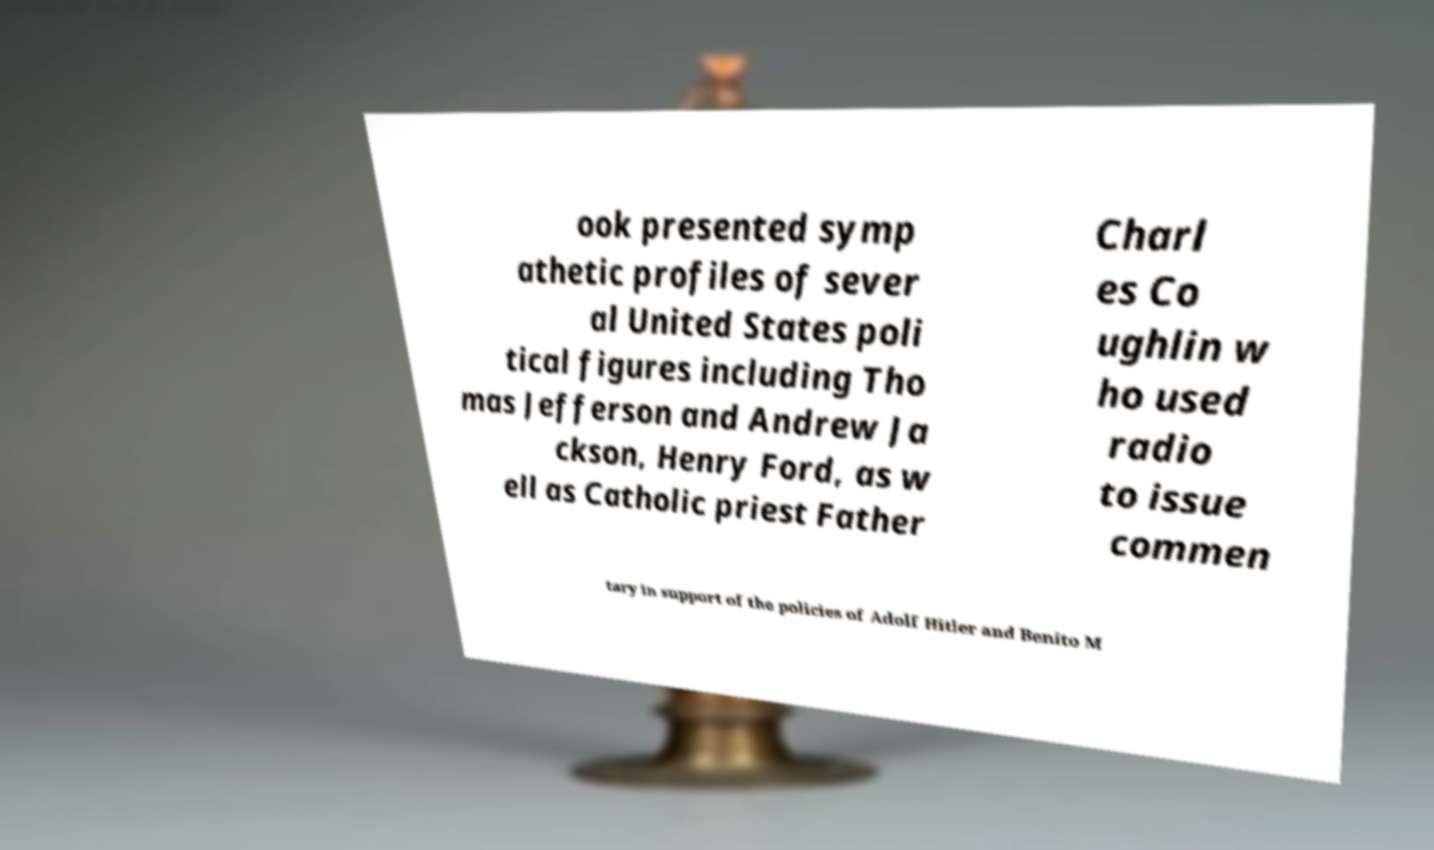Please identify and transcribe the text found in this image. ook presented symp athetic profiles of sever al United States poli tical figures including Tho mas Jefferson and Andrew Ja ckson, Henry Ford, as w ell as Catholic priest Father Charl es Co ughlin w ho used radio to issue commen tary in support of the policies of Adolf Hitler and Benito M 